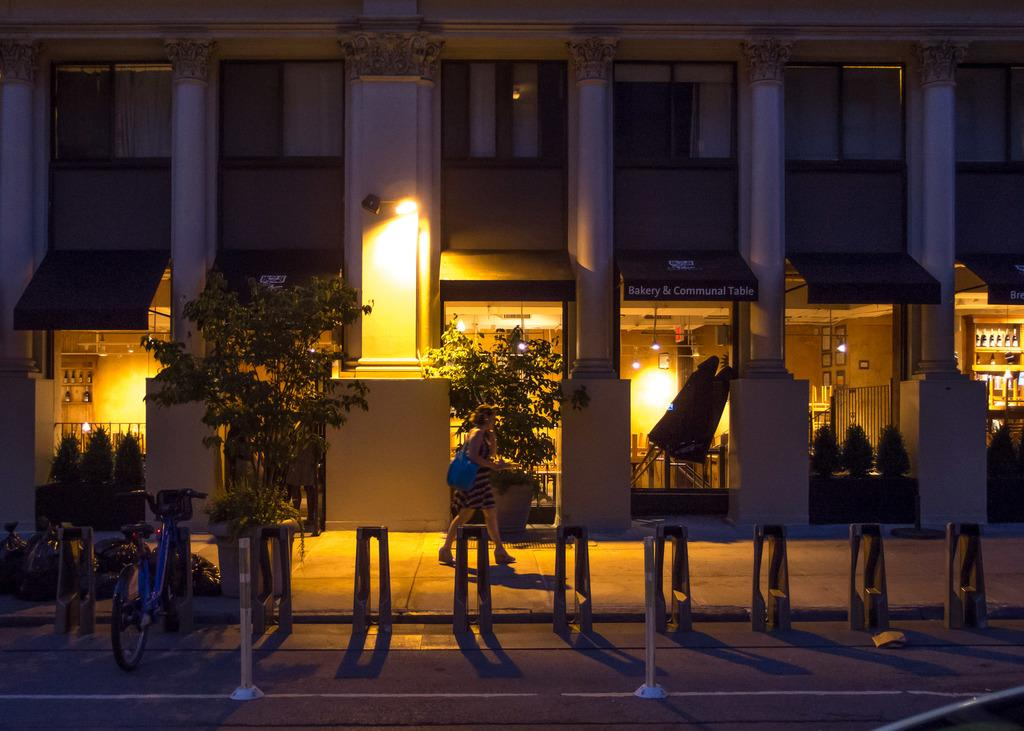What type of structure is visible in the image? There is a building in the image. What can be seen in the background of the image? There are trees and plants in the image. What type of illumination is present in the image? There are lights in the image. What architectural features can be seen in the image? There are pillars and poles in the image. What is the person in the image doing? The person is walking in the image. What is the person carrying while walking? The person is wearing a bag. What mode of transportation is visible in the image? There is a bicycle in the image. What type of gate can be seen in the image? There is no gate present in the image. How many men are visible in the image? There is only one person visible in the image, and they are not identified as a man. What type of rat can be seen interacting with the bicycle in the image? There are no rats present in the image; it only features a person walking and a bicycle. 